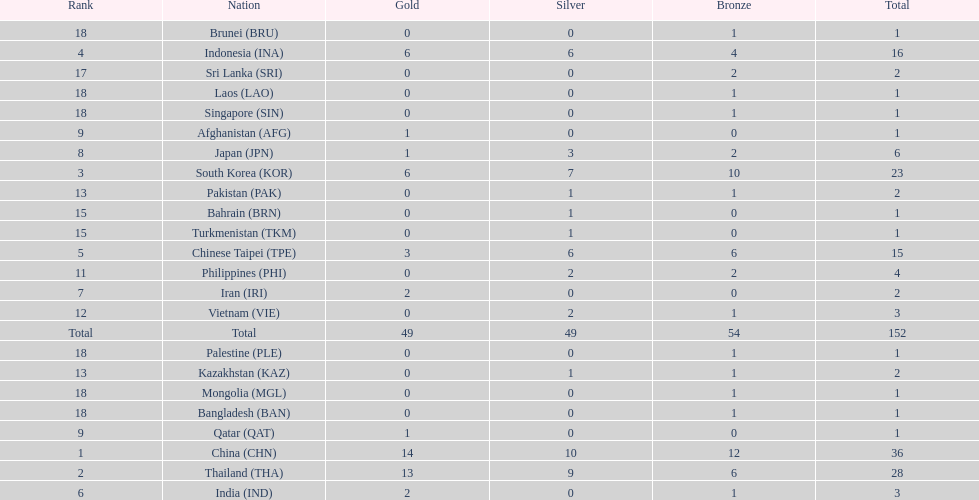How many nations received a medal in each gold, silver, and bronze? 6. 